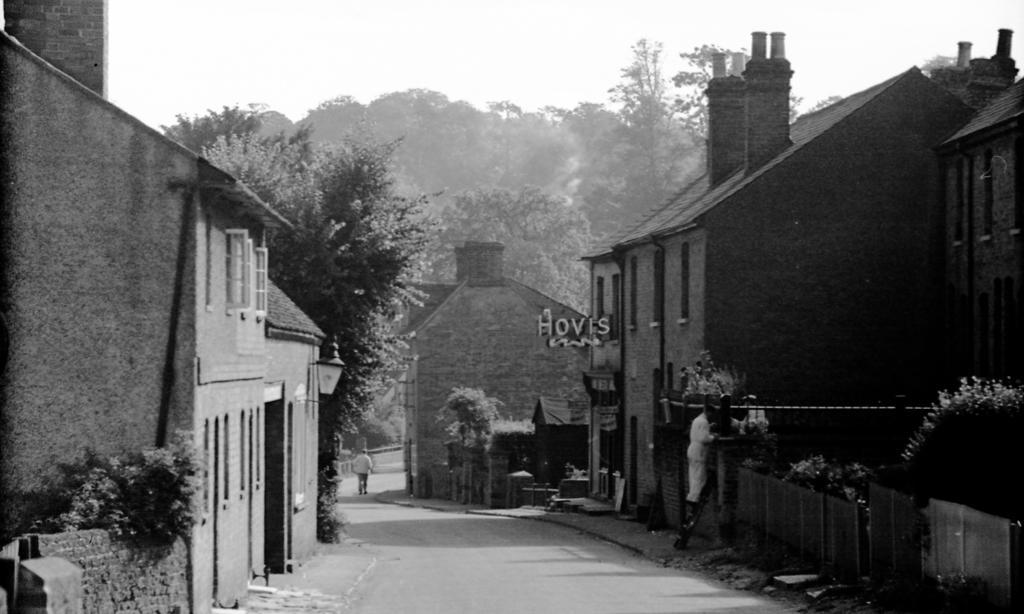In one or two sentences, can you explain what this image depicts? In the center of the image we can see houses, trees, boards, lamp are there. At the top of the image sky is there. At the bottom of the image road is there. On the right side of the image we can see fencing, plants and person are there. 